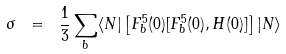<formula> <loc_0><loc_0><loc_500><loc_500>\sigma \ = \ \frac { 1 } { 3 } \sum _ { b } \langle N | \left [ F ^ { 5 } _ { b } ( 0 ) [ F ^ { 5 } _ { b } ( 0 ) , H ( 0 ) ] \right ] | N \rangle</formula> 